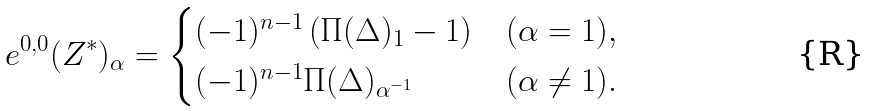<formula> <loc_0><loc_0><loc_500><loc_500>e ^ { 0 , 0 } ( Z ^ { * } ) _ { \alpha } = \begin{cases} ( - 1 ) ^ { n - 1 } \left ( \Pi ( \Delta ) _ { 1 } - 1 \right ) & ( \alpha = 1 ) , \\ ( - 1 ) ^ { n - 1 } \Pi ( \Delta ) _ { \alpha ^ { - 1 } } & ( \alpha \neq 1 ) . \end{cases}</formula> 